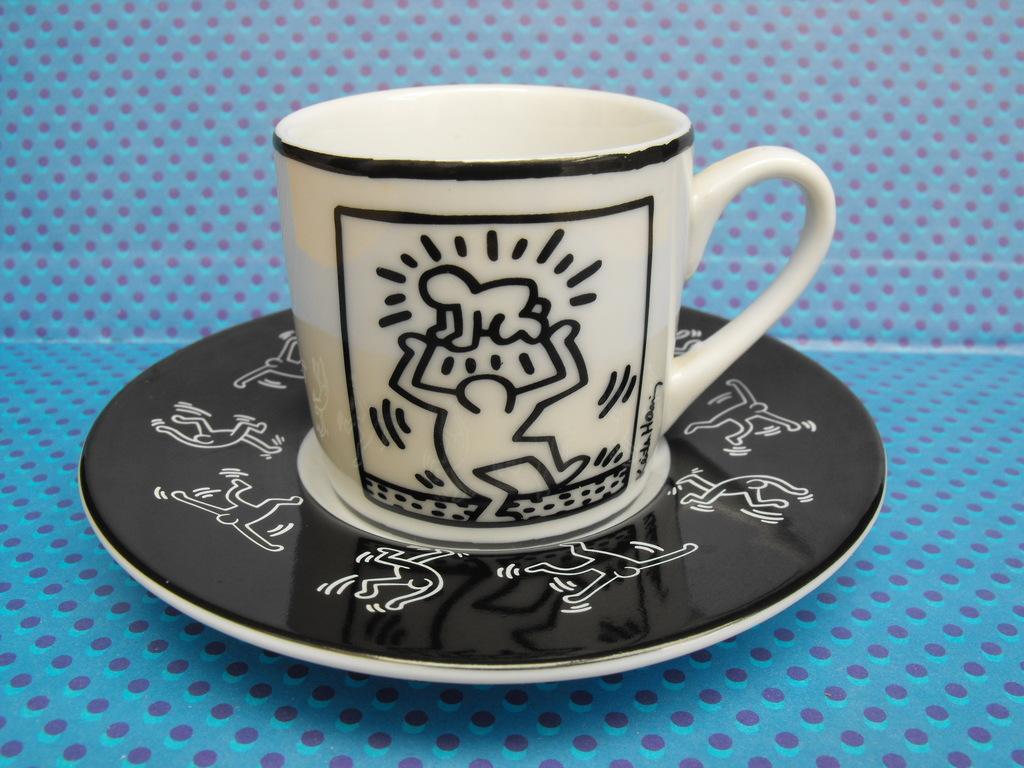Please provide a concise description of this image. In this image we can see a cup in a saucer placed on the surface. 